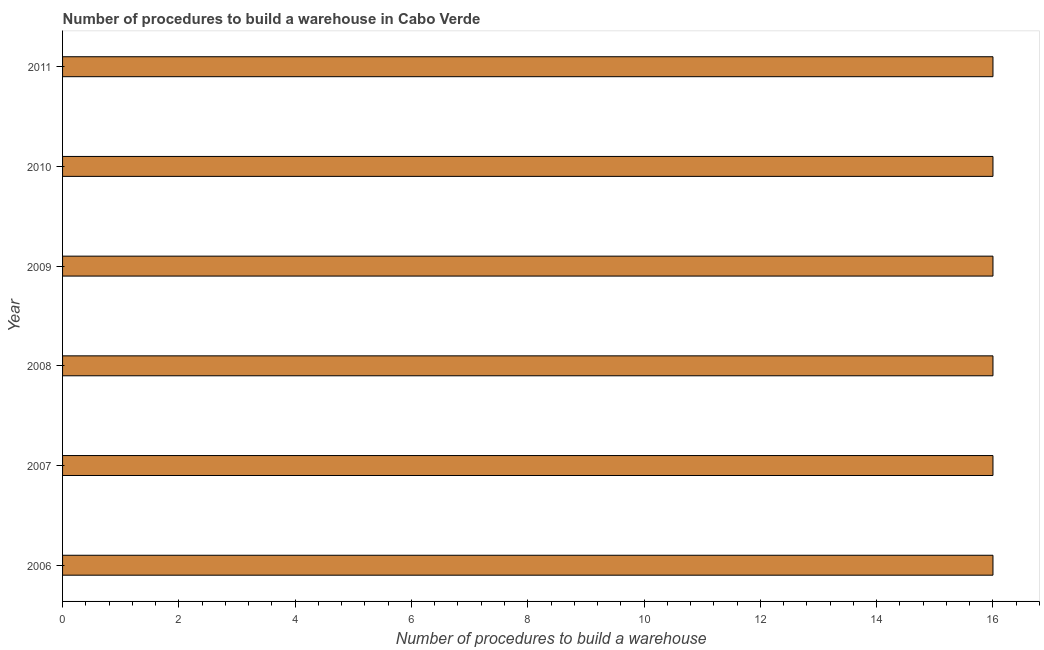Does the graph contain any zero values?
Make the answer very short. No. What is the title of the graph?
Provide a succinct answer. Number of procedures to build a warehouse in Cabo Verde. What is the label or title of the X-axis?
Make the answer very short. Number of procedures to build a warehouse. What is the label or title of the Y-axis?
Provide a succinct answer. Year. What is the number of procedures to build a warehouse in 2009?
Make the answer very short. 16. Across all years, what is the maximum number of procedures to build a warehouse?
Your answer should be very brief. 16. What is the sum of the number of procedures to build a warehouse?
Your response must be concise. 96. What is the difference between the number of procedures to build a warehouse in 2009 and 2011?
Give a very brief answer. 0. What is the median number of procedures to build a warehouse?
Ensure brevity in your answer.  16. In how many years, is the number of procedures to build a warehouse greater than 9.6 ?
Your response must be concise. 6. Do a majority of the years between 2007 and 2010 (inclusive) have number of procedures to build a warehouse greater than 12.4 ?
Give a very brief answer. Yes. What is the ratio of the number of procedures to build a warehouse in 2007 to that in 2008?
Make the answer very short. 1. What is the difference between the highest and the lowest number of procedures to build a warehouse?
Your answer should be compact. 0. How many bars are there?
Your answer should be very brief. 6. What is the difference between two consecutive major ticks on the X-axis?
Keep it short and to the point. 2. Are the values on the major ticks of X-axis written in scientific E-notation?
Offer a very short reply. No. What is the Number of procedures to build a warehouse of 2006?
Your response must be concise. 16. What is the Number of procedures to build a warehouse of 2009?
Give a very brief answer. 16. What is the Number of procedures to build a warehouse in 2011?
Make the answer very short. 16. What is the difference between the Number of procedures to build a warehouse in 2006 and 2007?
Make the answer very short. 0. What is the difference between the Number of procedures to build a warehouse in 2007 and 2010?
Keep it short and to the point. 0. What is the difference between the Number of procedures to build a warehouse in 2007 and 2011?
Offer a very short reply. 0. What is the difference between the Number of procedures to build a warehouse in 2008 and 2009?
Your answer should be compact. 0. What is the difference between the Number of procedures to build a warehouse in 2008 and 2010?
Provide a short and direct response. 0. What is the difference between the Number of procedures to build a warehouse in 2009 and 2010?
Your response must be concise. 0. What is the ratio of the Number of procedures to build a warehouse in 2006 to that in 2008?
Make the answer very short. 1. What is the ratio of the Number of procedures to build a warehouse in 2006 to that in 2009?
Make the answer very short. 1. What is the ratio of the Number of procedures to build a warehouse in 2006 to that in 2011?
Your response must be concise. 1. What is the ratio of the Number of procedures to build a warehouse in 2008 to that in 2009?
Keep it short and to the point. 1. What is the ratio of the Number of procedures to build a warehouse in 2008 to that in 2010?
Your response must be concise. 1. 